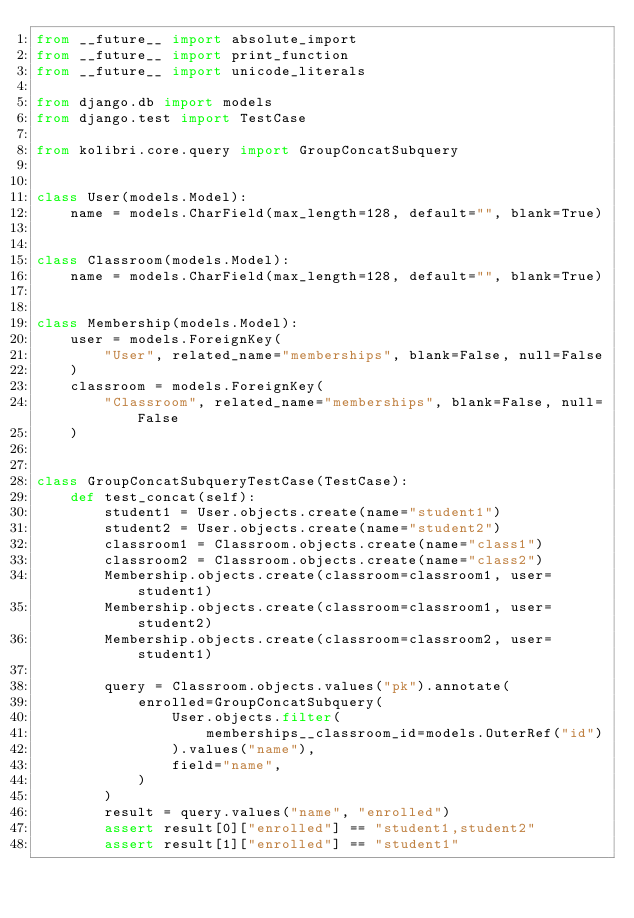Convert code to text. <code><loc_0><loc_0><loc_500><loc_500><_Python_>from __future__ import absolute_import
from __future__ import print_function
from __future__ import unicode_literals

from django.db import models
from django.test import TestCase

from kolibri.core.query import GroupConcatSubquery


class User(models.Model):
    name = models.CharField(max_length=128, default="", blank=True)


class Classroom(models.Model):
    name = models.CharField(max_length=128, default="", blank=True)


class Membership(models.Model):
    user = models.ForeignKey(
        "User", related_name="memberships", blank=False, null=False
    )
    classroom = models.ForeignKey(
        "Classroom", related_name="memberships", blank=False, null=False
    )


class GroupConcatSubqueryTestCase(TestCase):
    def test_concat(self):
        student1 = User.objects.create(name="student1")
        student2 = User.objects.create(name="student2")
        classroom1 = Classroom.objects.create(name="class1")
        classroom2 = Classroom.objects.create(name="class2")
        Membership.objects.create(classroom=classroom1, user=student1)
        Membership.objects.create(classroom=classroom1, user=student2)
        Membership.objects.create(classroom=classroom2, user=student1)

        query = Classroom.objects.values("pk").annotate(
            enrolled=GroupConcatSubquery(
                User.objects.filter(
                    memberships__classroom_id=models.OuterRef("id")
                ).values("name"),
                field="name",
            )
        )
        result = query.values("name", "enrolled")
        assert result[0]["enrolled"] == "student1,student2"
        assert result[1]["enrolled"] == "student1"
</code> 